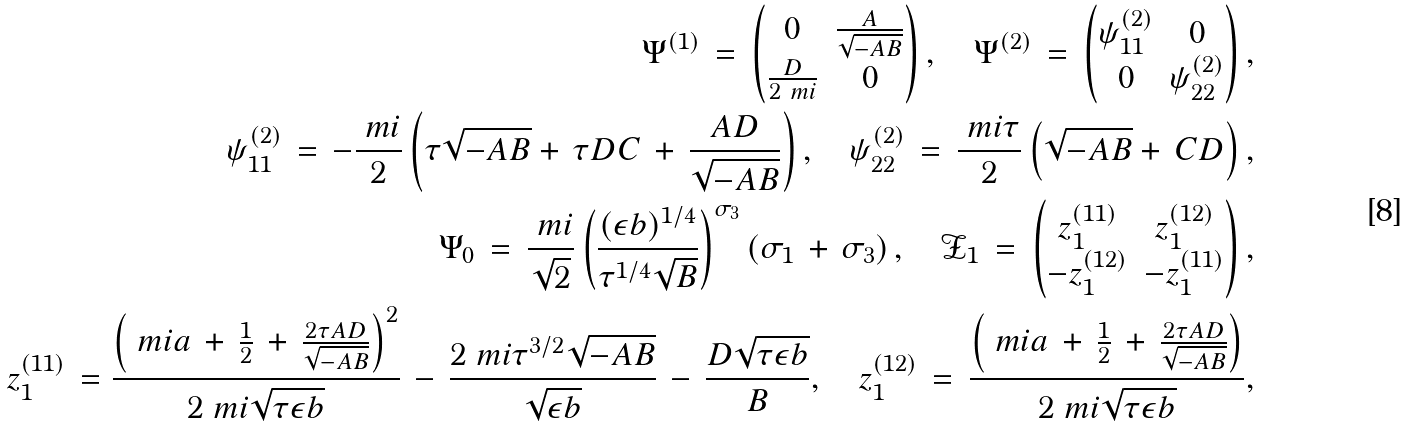Convert formula to latex. <formula><loc_0><loc_0><loc_500><loc_500>\Psi ^ { ( 1 ) } \, = \, \begin{pmatrix} 0 & \frac { A } { \sqrt { - A B } } \\ \frac { D } { 2 \ m i } & 0 \end{pmatrix} , \quad \Psi ^ { ( 2 ) } \, = \, \begin{pmatrix} \psi ^ { ( 2 ) } _ { 1 1 } & 0 \\ 0 & \psi ^ { ( 2 ) } _ { 2 2 } \end{pmatrix} , \\ \psi ^ { ( 2 ) } _ { 1 1 } \, = \, - \frac { \ m i } { 2 } \left ( \tau \sqrt { - A B } + \, \tau D C \, + \, \frac { A D } { \sqrt { - A B } } \right ) , \quad \psi ^ { ( 2 ) } _ { 2 2 } \, = \, \frac { \ m i \tau } { 2 } \left ( \sqrt { - A B } + \, C D \right ) , \\ \Psi _ { 0 } \, = \, \frac { \ m i } { \sqrt { 2 } } \left ( \frac { ( \epsilon b ) ^ { 1 / 4 } } { \tau ^ { 1 / 4 } \sqrt { B } } \right ) ^ { \sigma _ { 3 } } \left ( \sigma _ { 1 } \, + \, \sigma _ { 3 } \right ) , \quad \mathcal { Z } _ { 1 } \, = \, \begin{pmatrix} z _ { 1 } ^ { ( 1 1 ) } & z _ { 1 } ^ { ( 1 2 ) } \\ - z _ { 1 } ^ { ( 1 2 ) } & - z _ { 1 } ^ { ( 1 1 ) } \end{pmatrix} , \\ z _ { 1 } ^ { ( 1 1 ) } \, = \frac { \left ( \ m i a \, + \, \frac { 1 } { 2 } \, + \, \frac { 2 \tau A D } { \sqrt { - A B } } \right ) ^ { 2 } } { 2 \ m i \sqrt { \tau \epsilon b } } \, - \, \frac { 2 \ m i \tau ^ { 3 / 2 } \sqrt { - A B } } { \sqrt { \epsilon b } } \, - \, \frac { D \sqrt { \tau \epsilon b } } { B } , \quad z _ { 1 } ^ { ( 1 2 ) } \, = \, \frac { \left ( \ m i a \, + \, \frac { 1 } { 2 } \, + \, \frac { 2 \tau A D } { \sqrt { - A B } } \right ) } { 2 \ m i \sqrt { \tau \epsilon b } } ,</formula> 